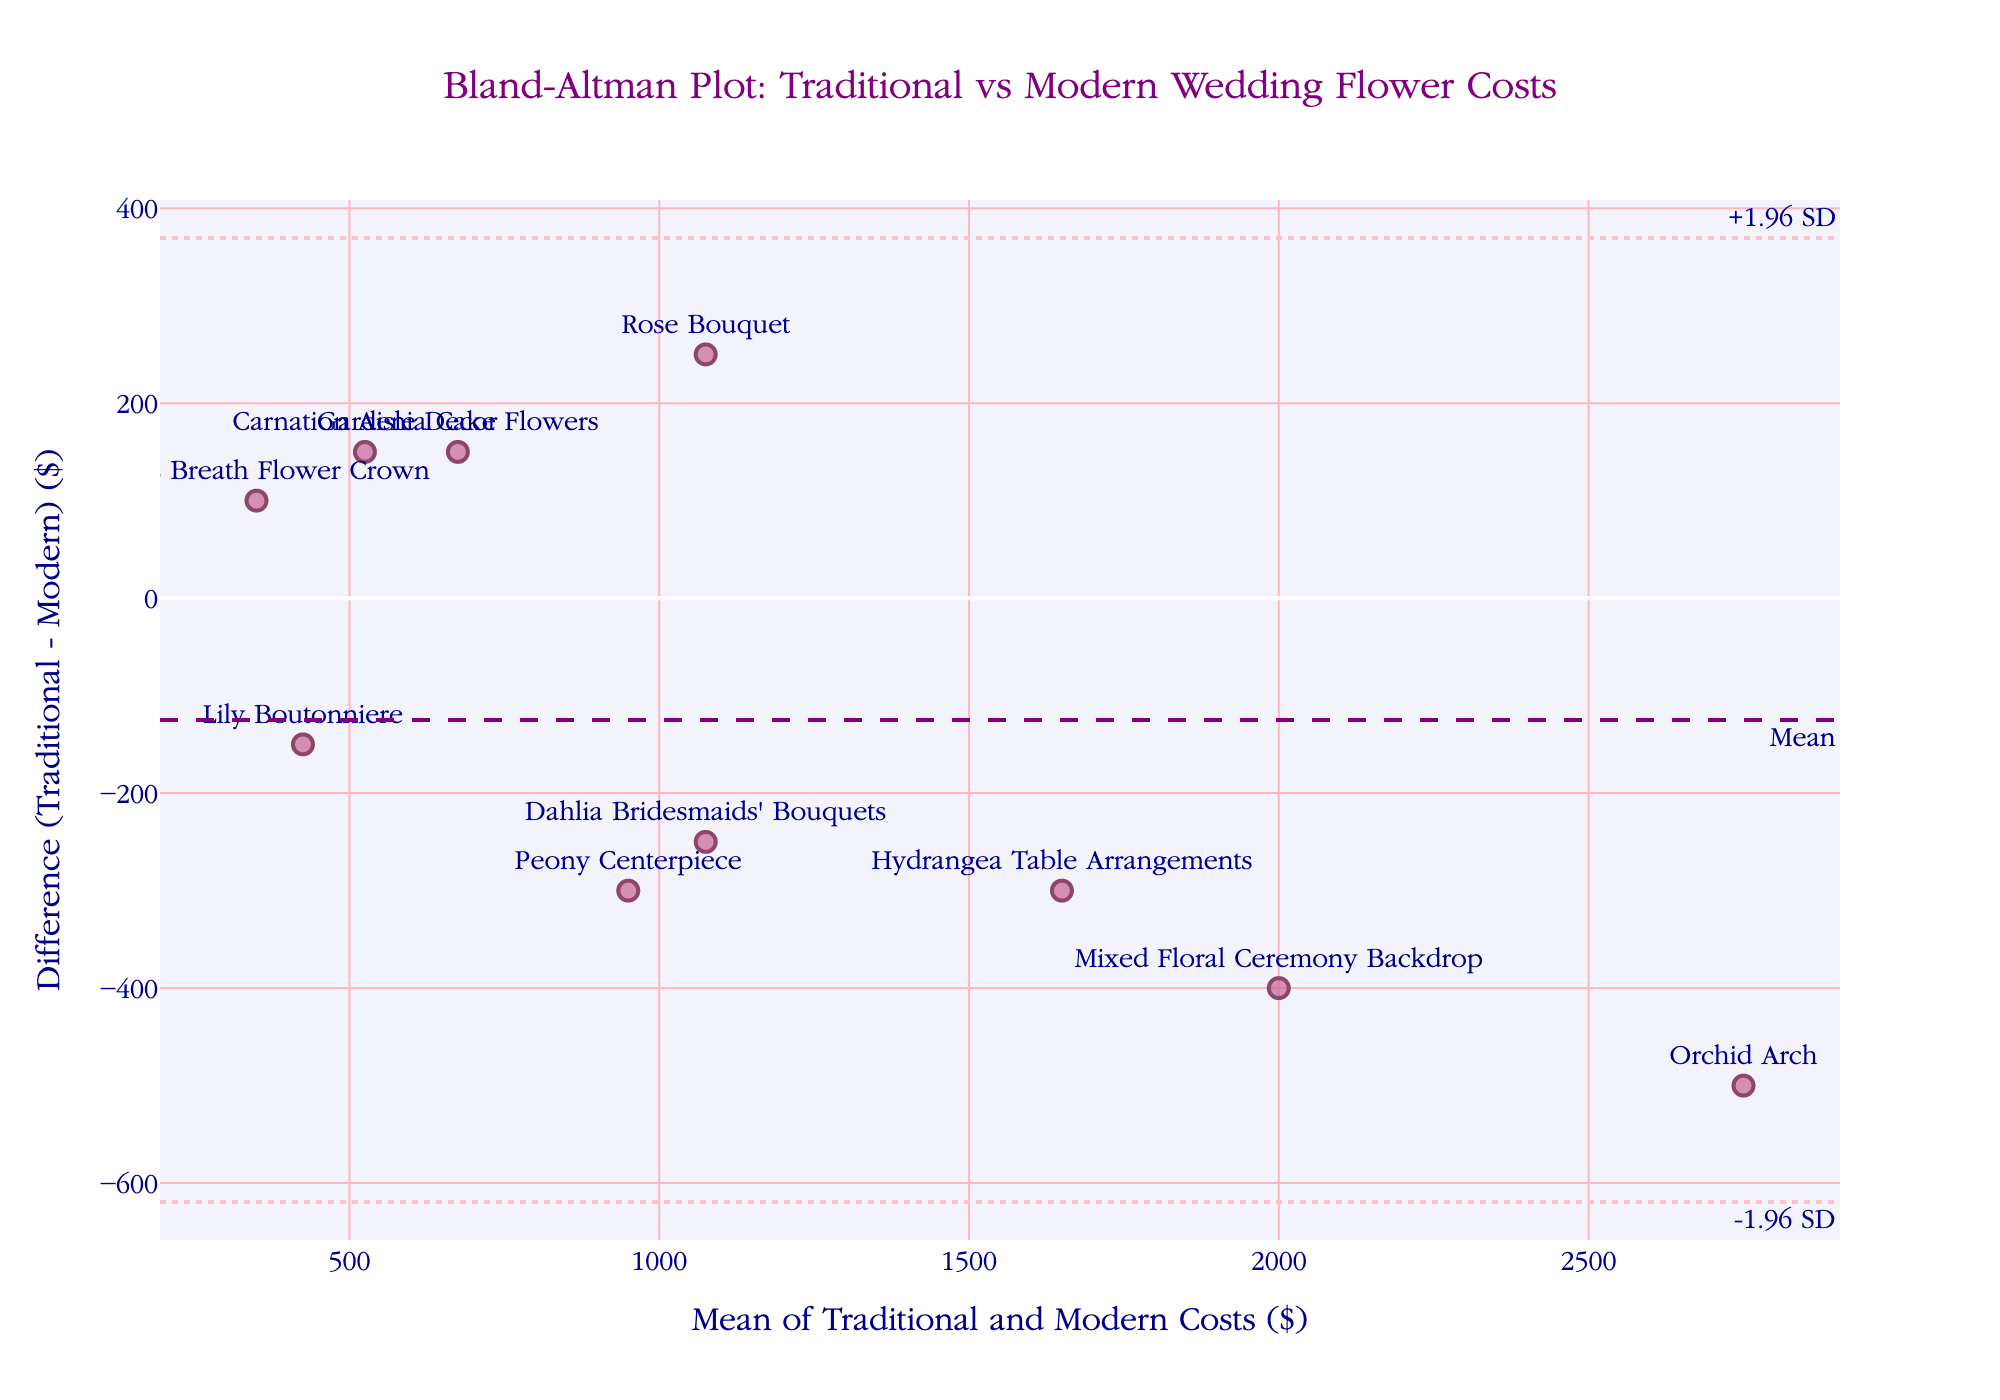What is the title of the plot? The title is displayed at the top center of the plot and reads "Bland-Altman Plot: Traditional vs Modern Wedding Flower Costs".
Answer: Bland-Altman Plot: Traditional vs Modern Wedding Flower Costs What do the x-axis and y-axis represent in this plot? The x-axis title is "Mean of Traditional and Modern Costs ($)", it represents the average cost of traditional and modern flowers. The y-axis title is "Difference (Traditional - Modern) ($)", it represents the cost difference between traditional and modern flowers.
Answer: Mean of Traditional and Modern Costs ($) and Difference (Traditional - Modern) ($) How many data points are displayed in the plot? The plot shows one marker for each row in the data, corresponding to the different flower types, and there are 10 rows of data.
Answer: 10 Which flower type has the greatest positive difference between traditional and modern costs? Locate the point with the highest position on the y-axis. The "Baby's Breath Flower Crown" has the greatest positive difference shown as a high value on the y-axis.
Answer: Baby's Breath Flower Crown What is the mean difference between traditional and modern costs, as indicated by the plot? The plot includes a dashed horizontal line labeled "Mean" at the y-value, which represents the mean difference.
Answer: approx. 25 Which flower type has the largest negative difference between traditional and modern costs? Identify the lowest point on the y-axis where the difference is negative. The "Orchid Arch" is the lowest data point, indicating it has the largest negative difference.
Answer: Orchid Arch Are there any flower types where the traditional and modern costs are equal? In a Bland-Altman plot, if the costs were equal, the point would lie on the y=0 line. No points lie on this line, indicating no flower types have equal traditional and modern costs.
Answer: No Which flower type is closest to the mean difference? Find the point nearest to the dashed horizontal line labeled "Mean". The "Hydrangea Table Arrangements" appears to be closest to this line.
Answer: Hydrangea Table Arrangements How does the range of cost differences compare to the mean cost difference? The plot shows dashed-dot lines labeled +1.96 SD and -1.96 SD around the mean difference indicating the range within which most data points fall. Compare the positions of these lines to understand the spread around the mean.
Answer: The cost differences vary significantly from mean Which flower type cost differences fall outside the +1.96 SD and -1.96 SD lines? Locate any points outside the dashed-dot lines. "Baby's Breath Flower Crown" falls above +1.96 SD, and "Orchid Arch" falls below -1.96 SD.
Answer: Baby's Breath Flower Crown and Orchid Arch 